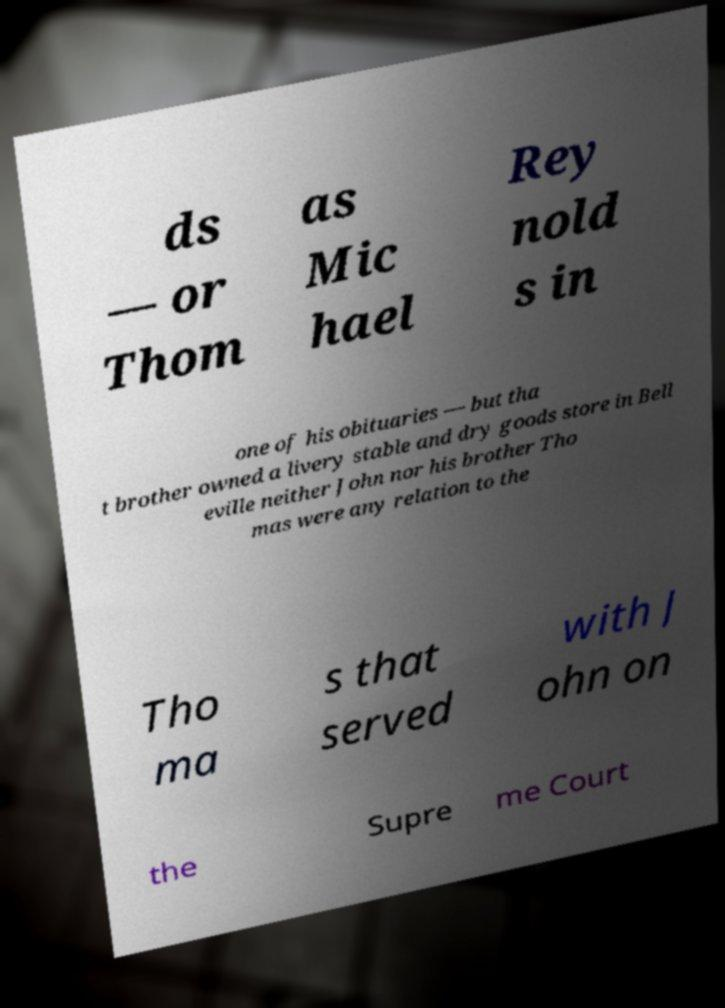Could you assist in decoding the text presented in this image and type it out clearly? ds — or Thom as Mic hael Rey nold s in one of his obituaries — but tha t brother owned a livery stable and dry goods store in Bell eville neither John nor his brother Tho mas were any relation to the Tho ma s that served with J ohn on the Supre me Court 